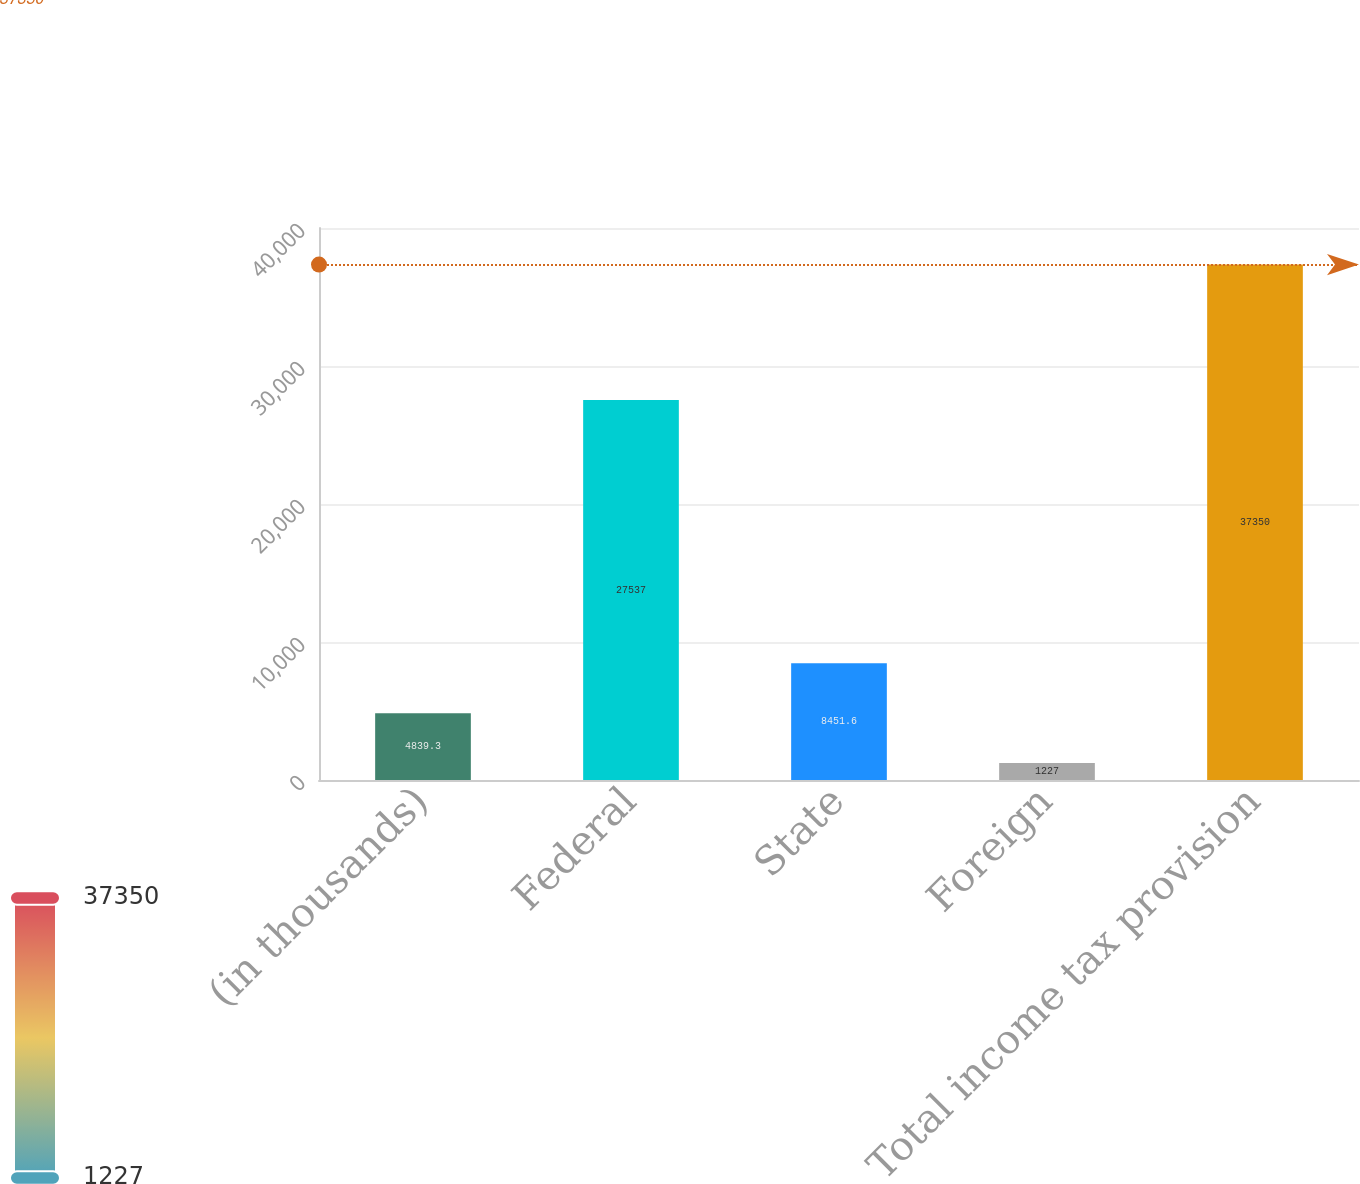Convert chart. <chart><loc_0><loc_0><loc_500><loc_500><bar_chart><fcel>(in thousands)<fcel>Federal<fcel>State<fcel>Foreign<fcel>Total income tax provision<nl><fcel>4839.3<fcel>27537<fcel>8451.6<fcel>1227<fcel>37350<nl></chart> 